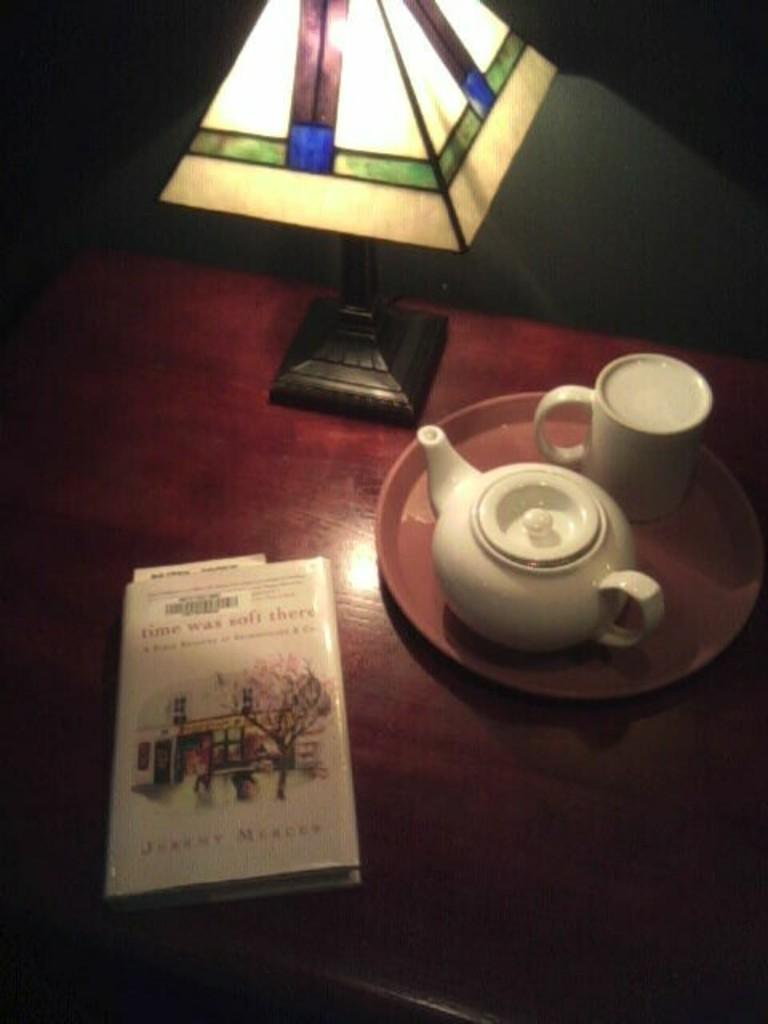What type of container is visible in the image? There is a cup in the image. What other container can be seen in the image? There is a jar in the image. What object is used for holding or serving food in the image? There is a plate in the image. What non-container object is present in the image? There is a book in the image. What light source is visible in the image? There is a lamp in the image. Where are all these objects located in the image? All of these objects are placed on a table. What can be seen in the background of the image? There is a wall in the background of the image. What type of canvas is hanging on the wall in the image? There is no canvas present in the image; only a wall is visible in the background. What is the chemical composition of the zinc in the image? There is no zinc present in the image, so its chemical composition cannot be determined. 